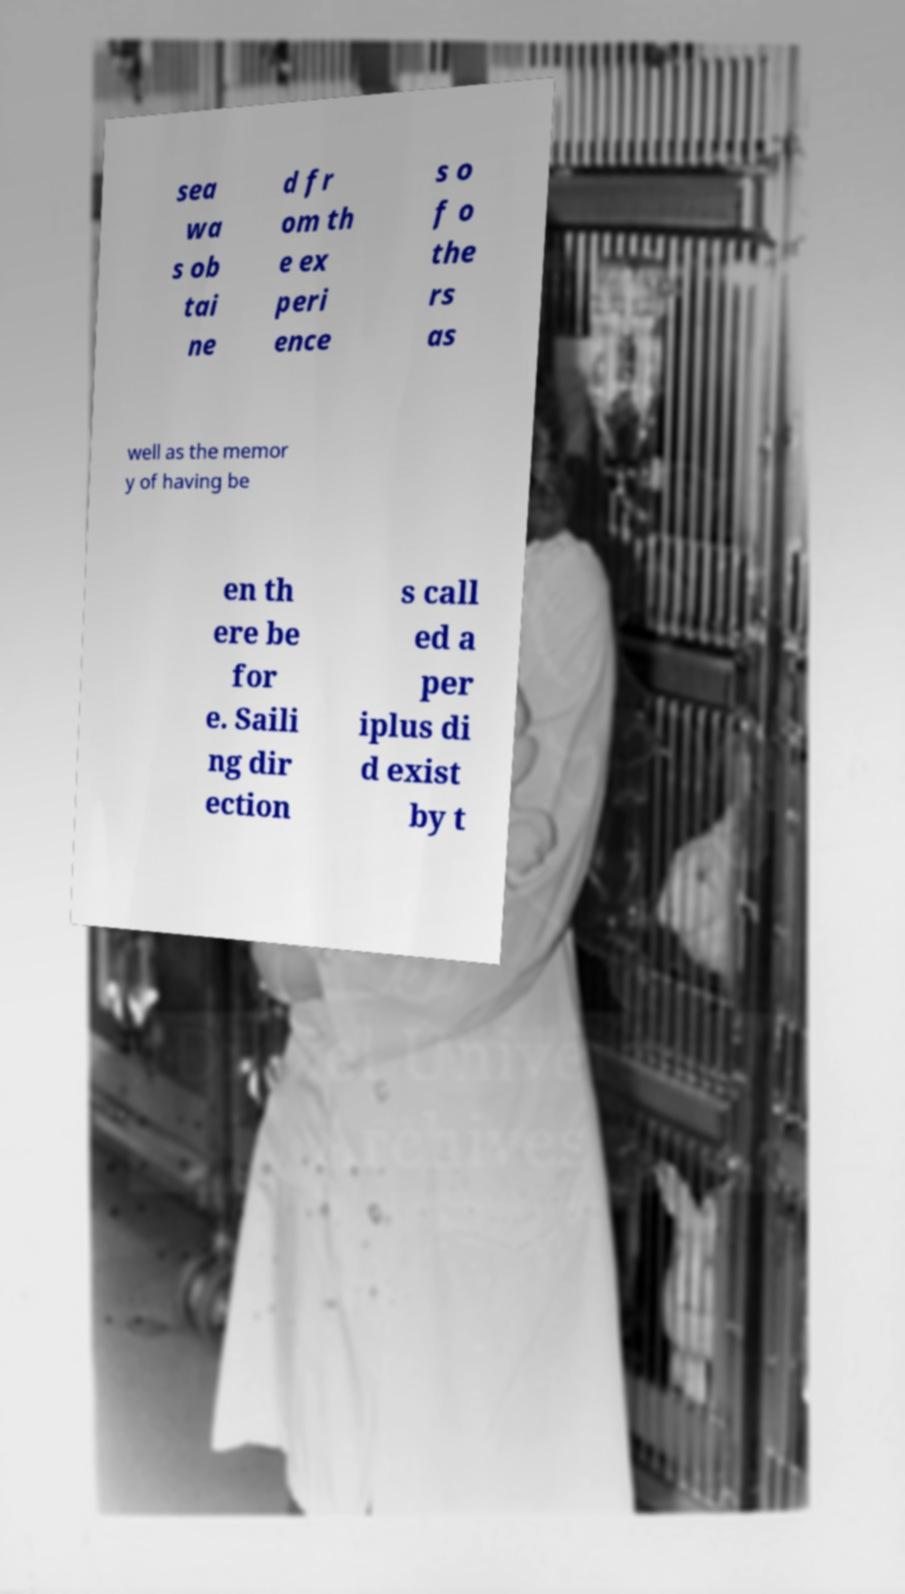Please read and relay the text visible in this image. What does it say? sea wa s ob tai ne d fr om th e ex peri ence s o f o the rs as well as the memor y of having be en th ere be for e. Saili ng dir ection s call ed a per iplus di d exist by t 